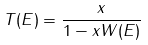<formula> <loc_0><loc_0><loc_500><loc_500>T ( E ) = \frac { x } { 1 - x W ( E ) }</formula> 